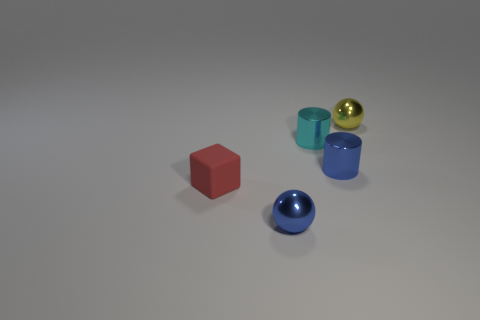Add 3 tiny rubber things. How many objects exist? 8 Subtract all blue cylinders. How many cylinders are left? 1 Subtract all cyan cylinders. How many blue spheres are left? 1 Add 1 cyan cylinders. How many cyan cylinders are left? 2 Add 4 cyan cylinders. How many cyan cylinders exist? 5 Subtract 0 brown spheres. How many objects are left? 5 Subtract all spheres. How many objects are left? 3 Subtract 1 cubes. How many cubes are left? 0 Subtract all cyan spheres. Subtract all green cylinders. How many spheres are left? 2 Subtract all small green shiny blocks. Subtract all small cylinders. How many objects are left? 3 